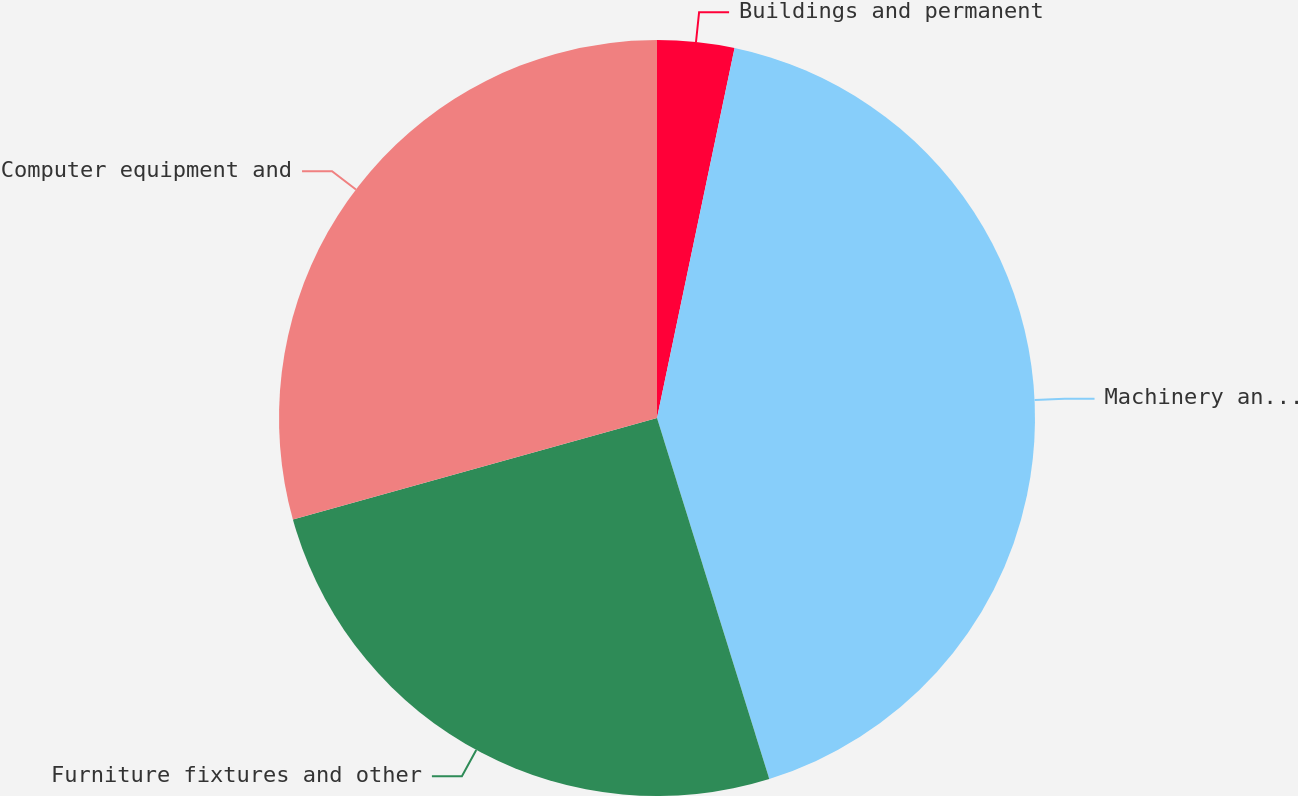Convert chart to OTSL. <chart><loc_0><loc_0><loc_500><loc_500><pie_chart><fcel>Buildings and permanent<fcel>Machinery and warehouse<fcel>Furniture fixtures and other<fcel>Computer equipment and<nl><fcel>3.29%<fcel>41.91%<fcel>25.47%<fcel>29.33%<nl></chart> 